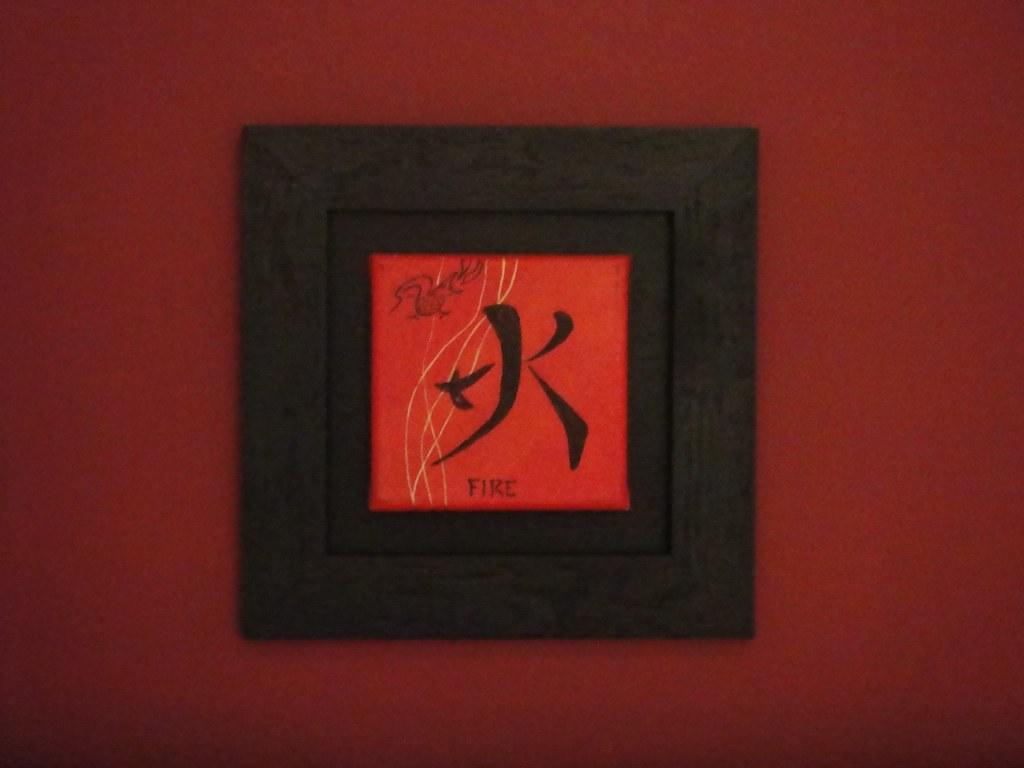What english word is on this framed drawing?
Your response must be concise. Fire. 